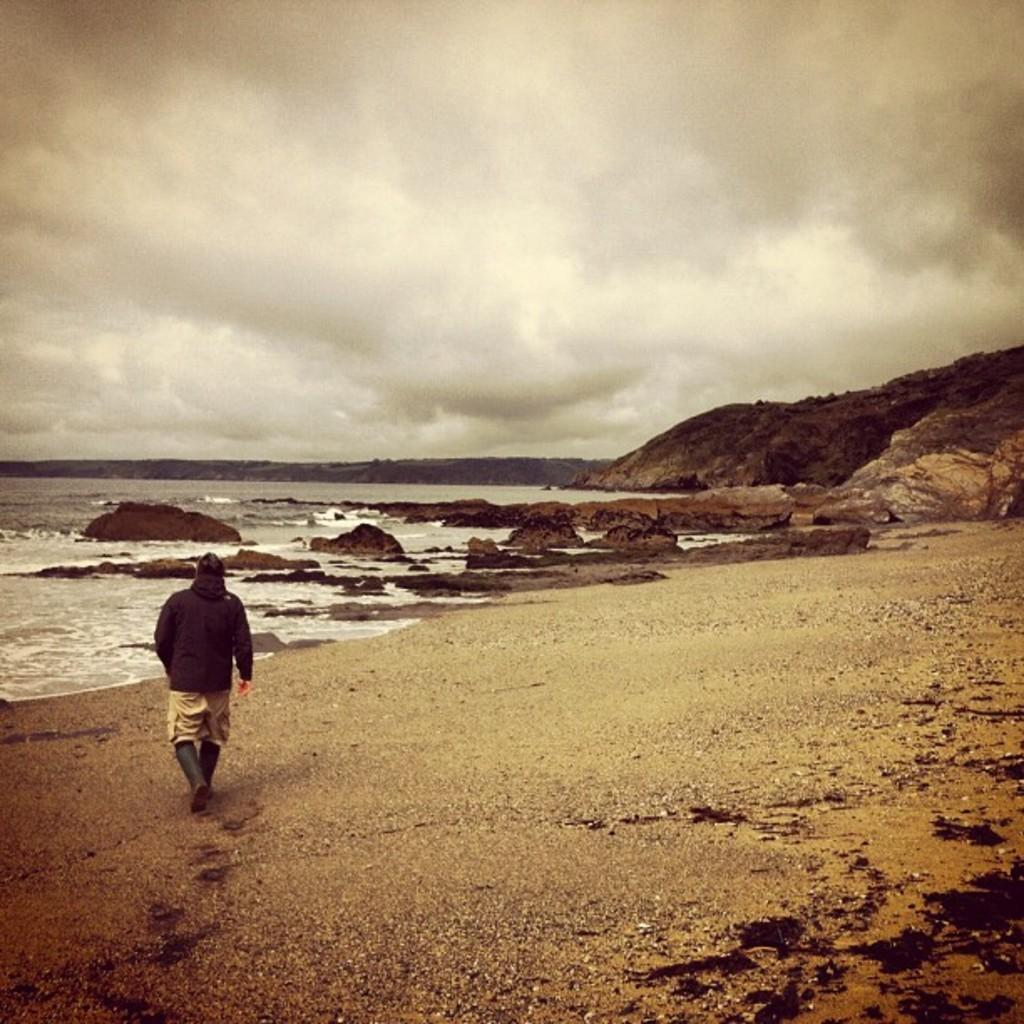What is the person in the image doing? There is a person walking in the image. What type of terrain is visible at the bottom of the image? There is sand at the bottom of the image. What type of natural landscape can be seen to the left of the image? There is a beach to the left of the image. What type of natural landscape can be seen to the right of the image? There are mountains to the right of the image. What is visible in the sky at the top of the image? There are clouds visible in the sky at the top of the image. Where is the nearest hospital to the person walking in the image? There is no information about a hospital in the image, so it cannot be determined from the image. 